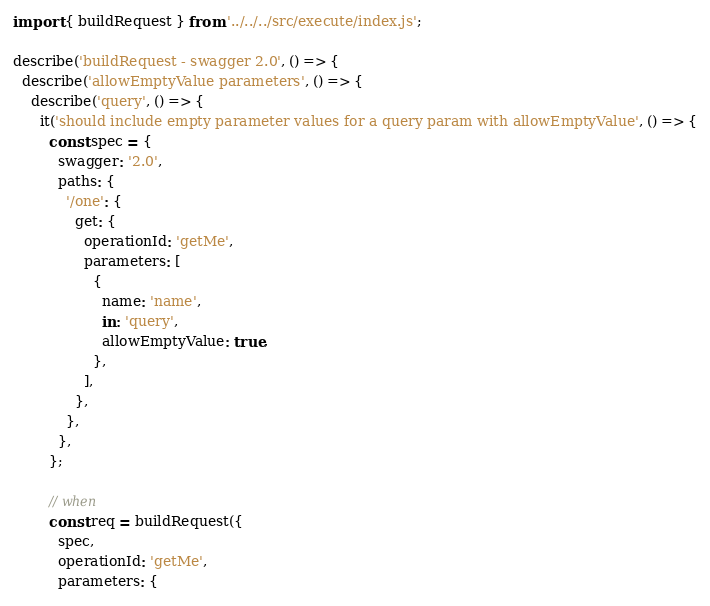Convert code to text. <code><loc_0><loc_0><loc_500><loc_500><_JavaScript_>import { buildRequest } from '../../../src/execute/index.js';

describe('buildRequest - swagger 2.0', () => {
  describe('allowEmptyValue parameters', () => {
    describe('query', () => {
      it('should include empty parameter values for a query param with allowEmptyValue', () => {
        const spec = {
          swagger: '2.0',
          paths: {
            '/one': {
              get: {
                operationId: 'getMe',
                parameters: [
                  {
                    name: 'name',
                    in: 'query',
                    allowEmptyValue: true,
                  },
                ],
              },
            },
          },
        };

        // when
        const req = buildRequest({
          spec,
          operationId: 'getMe',
          parameters: {</code> 